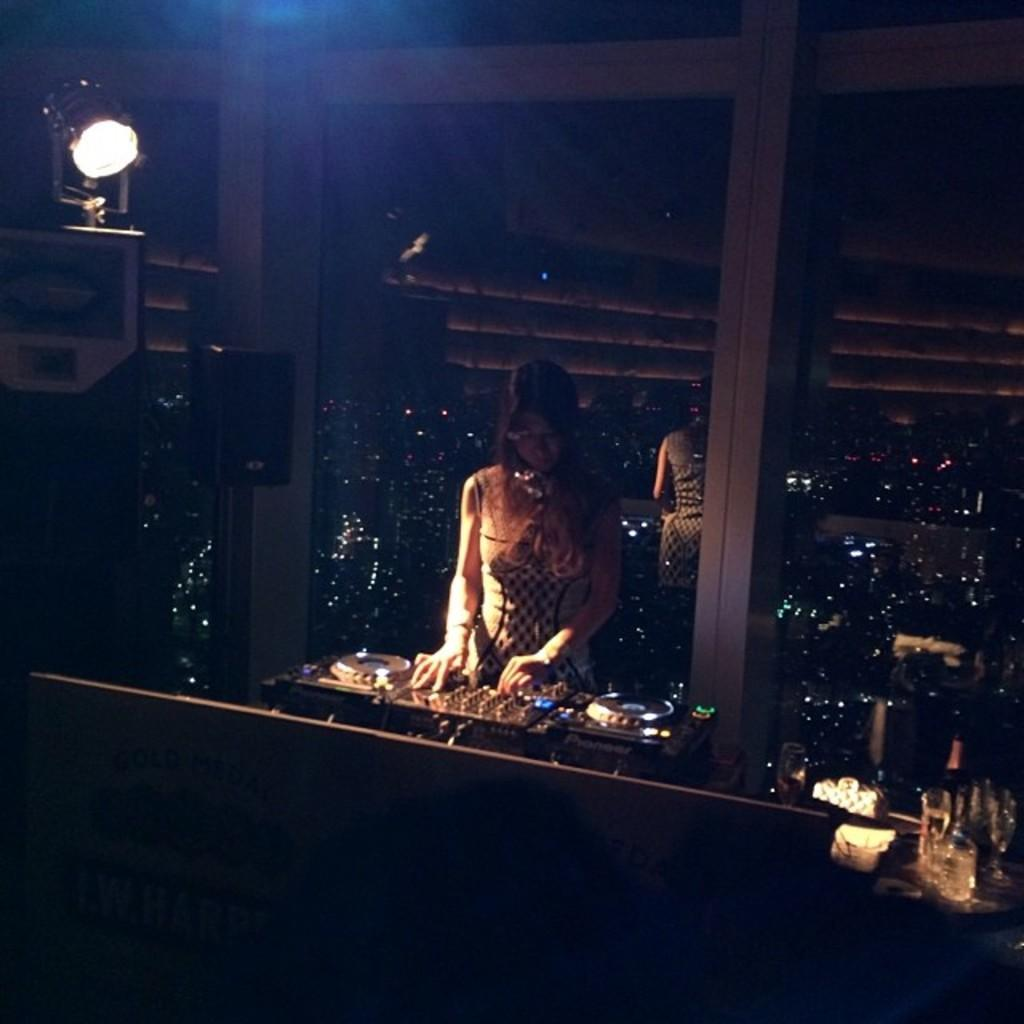What is the woman in the image doing? The woman is playing a DJ in the image. What can be seen beside the woman? There is a sound box beside the woman. Are there any other people in the image? Yes, there is another woman standing in the image. What type of pleasure can be smelled coming from the sound box in the image? There is no indication of any smell or pleasure in the image, as it features a woman playing a DJ and a sound box. 